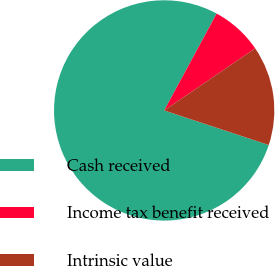<chart> <loc_0><loc_0><loc_500><loc_500><pie_chart><fcel>Cash received<fcel>Income tax benefit received<fcel>Intrinsic value<nl><fcel>77.82%<fcel>7.58%<fcel>14.6%<nl></chart> 